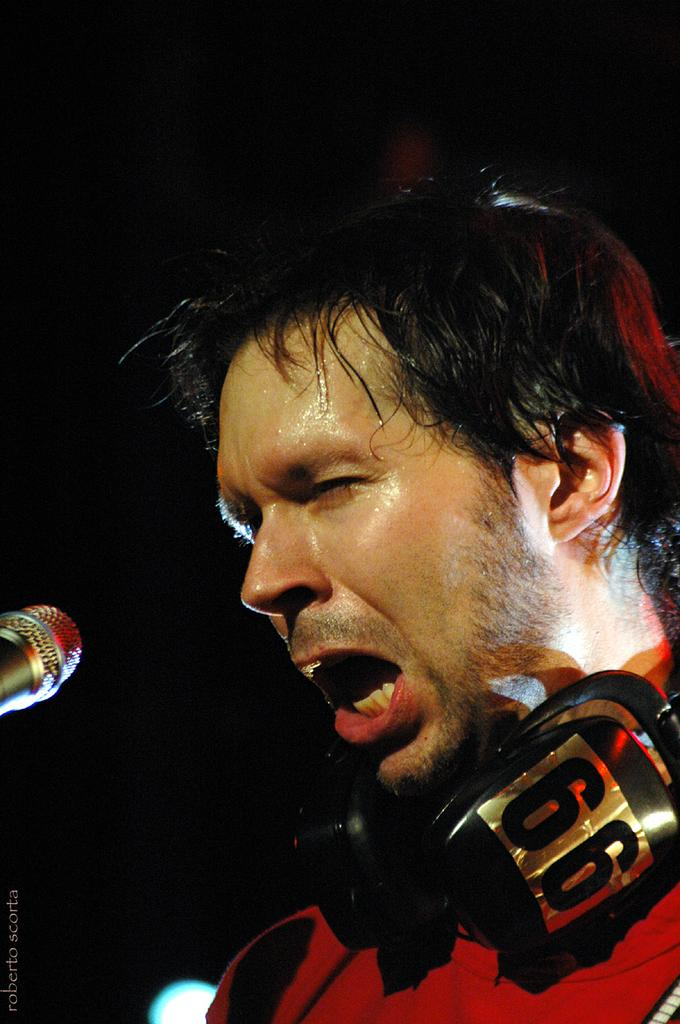What is located on the right side of the image? There is a man and a microphone on the right side of the image. What is the man wearing or holding in the image? The man has a headset on his neck. What is the color or lighting condition of the background in the image? The background of the image is dark. Can you see a toad holding a rifle in the image? There is no toad or rifle present in the image. 